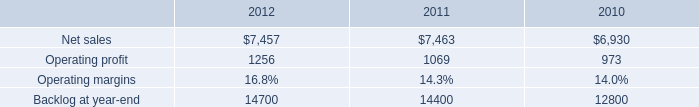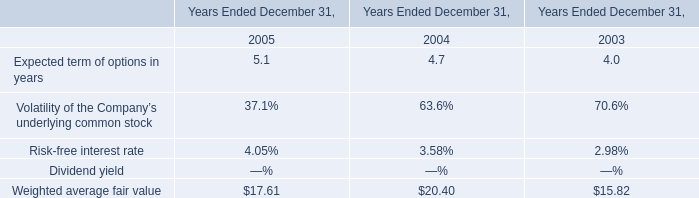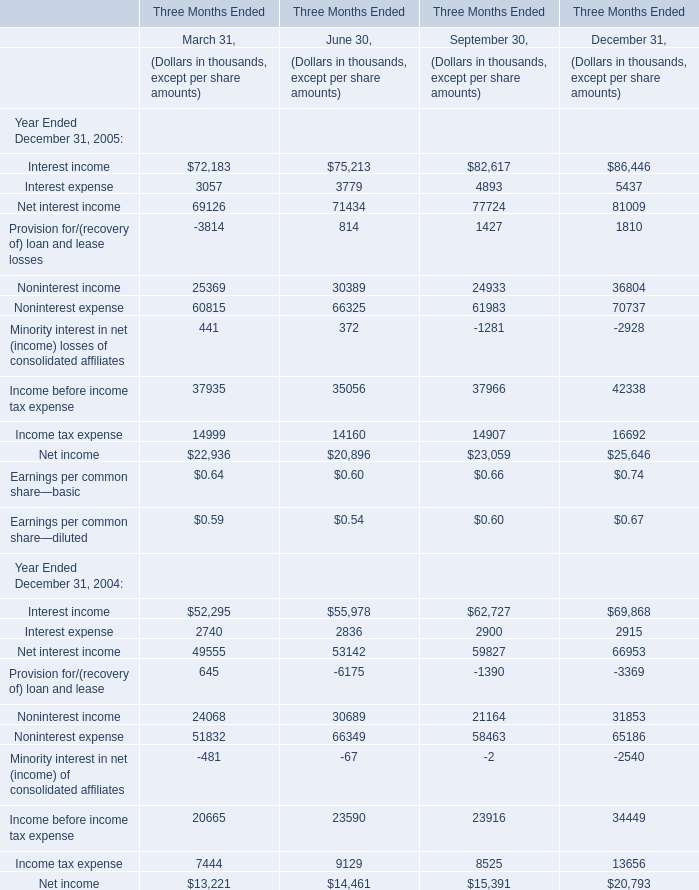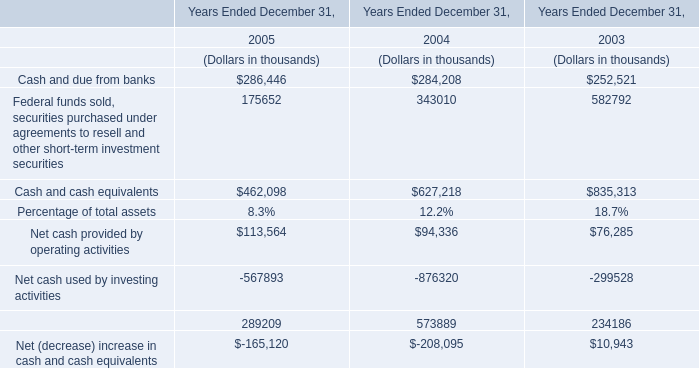What's the greatest value of Interest expense in 2005? (in thousand) 
Answer: 5437. what is the growth rate in net sales for mfc in 2012? 
Computations: ((7457 - 7463) / 7463)
Answer: -0.0008. 